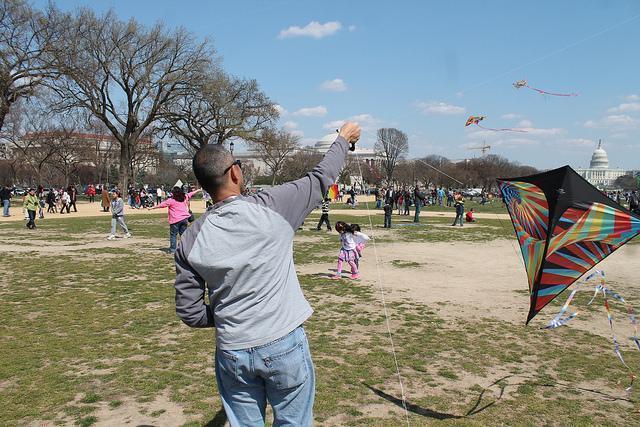Where would more well known government workers work here?
Select the accurate answer and provide justification: `Answer: choice
Rationale: srationale.`
Options: Rightmost building, middle building, leftmost building, park. Answer: rightmost building.
Rationale: The building has a recognizable color and dome shape on top of it. 